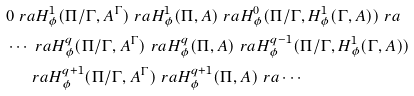Convert formula to latex. <formula><loc_0><loc_0><loc_500><loc_500>& 0 \ r a H ^ { 1 } _ { \phi } ( \Pi / \Gamma , A ^ { \Gamma } ) \ r a H ^ { 1 } _ { \phi } ( \Pi , A ) \ r a H ^ { 0 } _ { \phi } ( \Pi / \Gamma , H ^ { 1 } _ { \phi } ( \Gamma , A ) ) \ r a \\ & \cdots \ r a H ^ { q } _ { \phi } ( \Pi / \Gamma , A ^ { \Gamma } ) \ r a H ^ { q } _ { \phi } ( \Pi , A ) \ r a H ^ { q - 1 } _ { \phi } ( \Pi / \Gamma , H ^ { 1 } _ { \phi } ( \Gamma , A ) ) \\ & \quad \ \ r a H ^ { q + 1 } _ { \phi } ( \Pi / \Gamma , A ^ { \Gamma } ) \ r a H ^ { q + 1 } _ { \phi } ( \Pi , A ) \ r a \cdots</formula> 